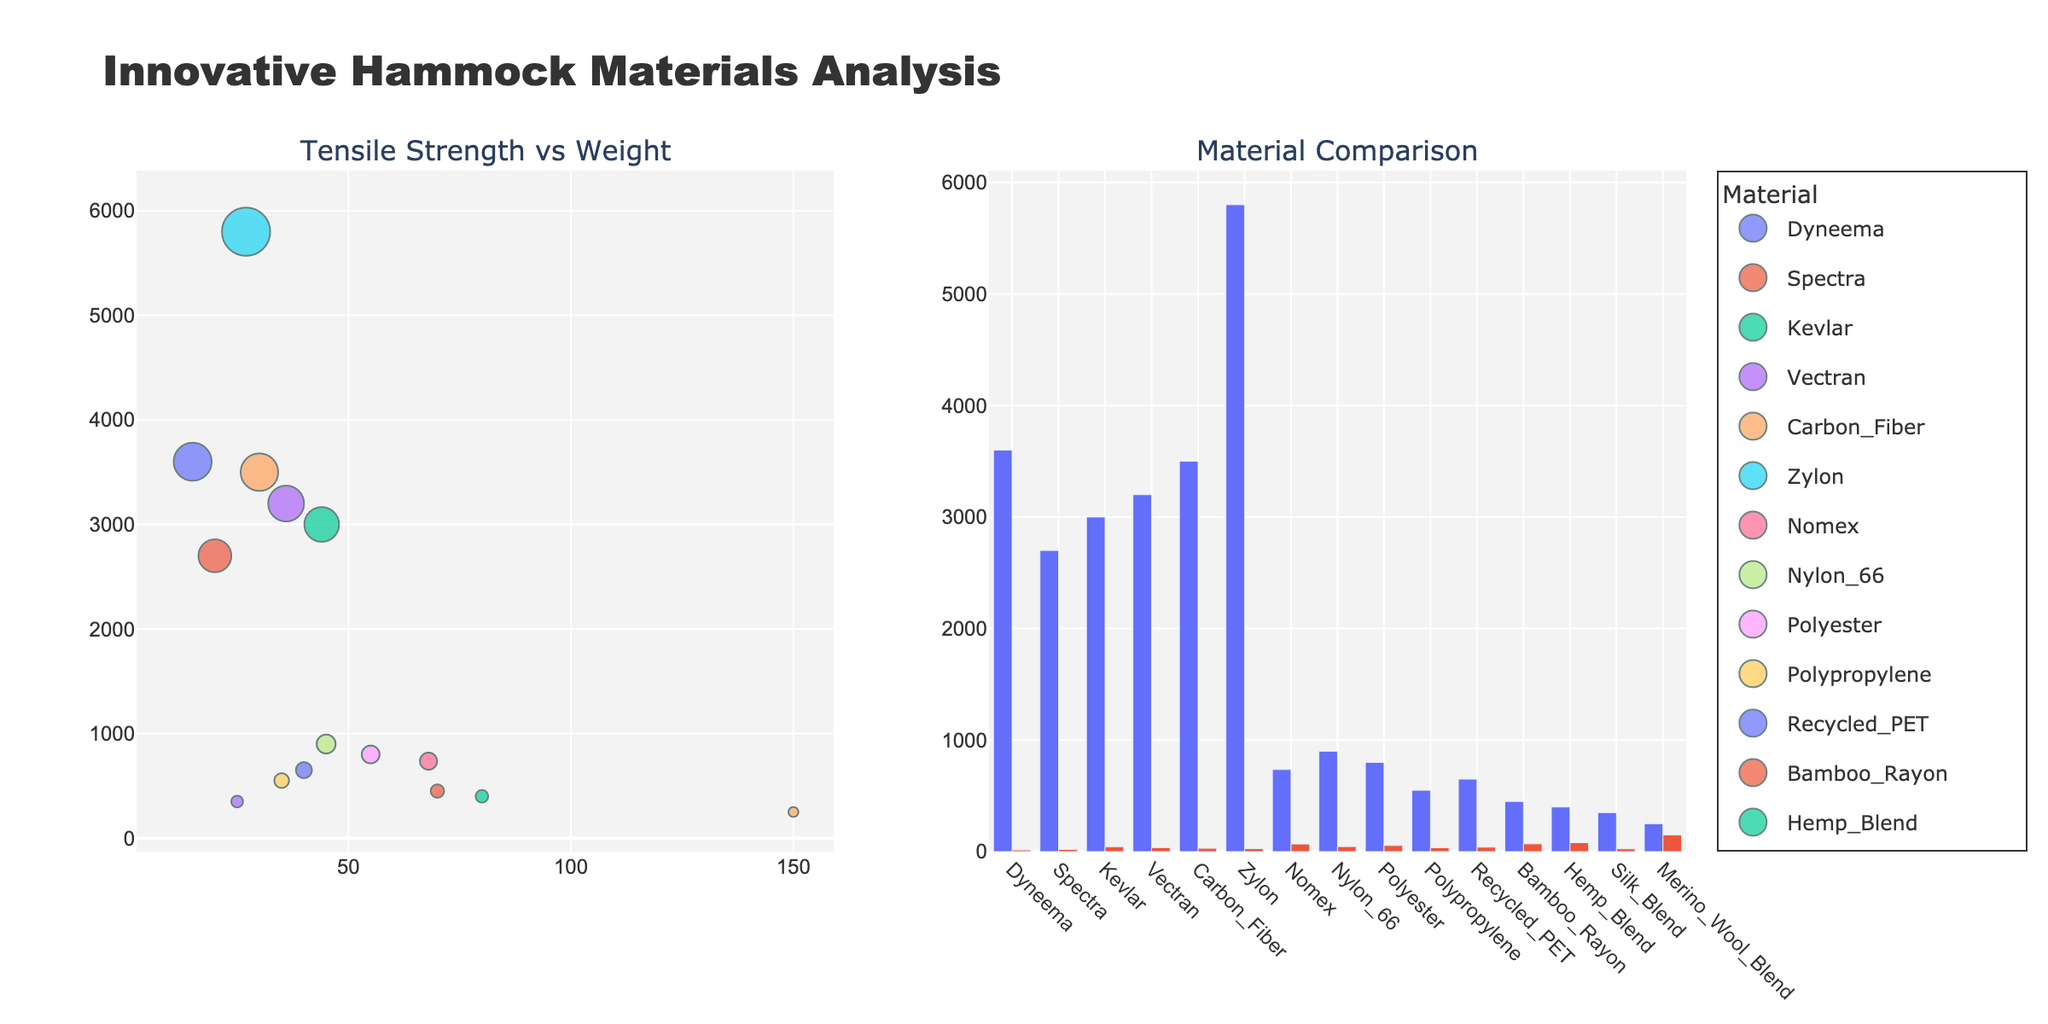What is the title of the scatter plot on the left? The title of the scatter plot on the left can be found above the plot, indicating the content being visualized.
Answer: Tensile Strength vs Weight Which material has the highest tensile strength? Locate the material with the highest point on the y-axis (Tensile Strength) in the scatter plot.
Answer: Zylon Which materials have the lowest weight? Identify the materials with the leftmost points on the x-axis (Weight).
Answer: Dyneema What is the relationship between the tensile strength and weight of Dyneema? Find the data point for Dyneema in the scatter plot and check its position relative to both axes.
Answer: High tensile strength, low weight How many materials are plotted in both the scatter and bar plots? Count the distinct materials represented by different colors and labels in both plots.
Answer: 15 Which material appears to be the lightest among the ones with a tensile strength greater than 2000 MPa? Filter the scatter plot for points above 2000 MPa on the y-axis and compare their positions on the x-axis (Weight).
Answer: Dyneema Compare the tensile strength of Kevlar and Carbon Fiber. Which one is stronger? Locate the points and bar segments for Kevlar and Carbon Fiber and compare their positions on the y-axis (Tensile Strength).
Answer: Carbon Fiber Which material has the highest weight among the ones shown in the bar plot? Look for the tallest bar segment in the "Weight" category.
Answer: Merino Wool Blend Is there a material with both high tensile strength and high weight? Identify materials in the scatter plot that are located towards the upper right corner of the plot.
Answer: Nomex Which metric (tensile strength or weight) has a more significant range of values among the materials? Compare the range of values for both axes in the scatter plot.
Answer: Tensile strength 